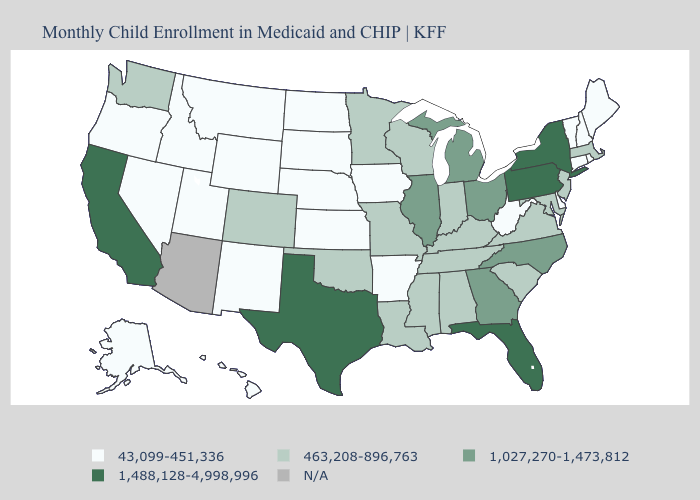What is the highest value in states that border Alabama?
Answer briefly. 1,488,128-4,998,996. Which states have the highest value in the USA?
Keep it brief. California, Florida, New York, Pennsylvania, Texas. Name the states that have a value in the range 43,099-451,336?
Concise answer only. Alaska, Arkansas, Connecticut, Delaware, Hawaii, Idaho, Iowa, Kansas, Maine, Montana, Nebraska, Nevada, New Hampshire, New Mexico, North Dakota, Oregon, Rhode Island, South Dakota, Utah, Vermont, West Virginia, Wyoming. Does Wisconsin have the highest value in the MidWest?
Answer briefly. No. Name the states that have a value in the range 1,027,270-1,473,812?
Write a very short answer. Georgia, Illinois, Michigan, North Carolina, Ohio. What is the value of Maine?
Write a very short answer. 43,099-451,336. Name the states that have a value in the range N/A?
Quick response, please. Arizona. Does the map have missing data?
Write a very short answer. Yes. What is the value of Vermont?
Keep it brief. 43,099-451,336. Name the states that have a value in the range 463,208-896,763?
Be succinct. Alabama, Colorado, Indiana, Kentucky, Louisiana, Maryland, Massachusetts, Minnesota, Mississippi, Missouri, New Jersey, Oklahoma, South Carolina, Tennessee, Virginia, Washington, Wisconsin. What is the value of Alabama?
Answer briefly. 463,208-896,763. How many symbols are there in the legend?
Concise answer only. 5. What is the highest value in states that border Arizona?
Concise answer only. 1,488,128-4,998,996. What is the value of Oregon?
Concise answer only. 43,099-451,336. 